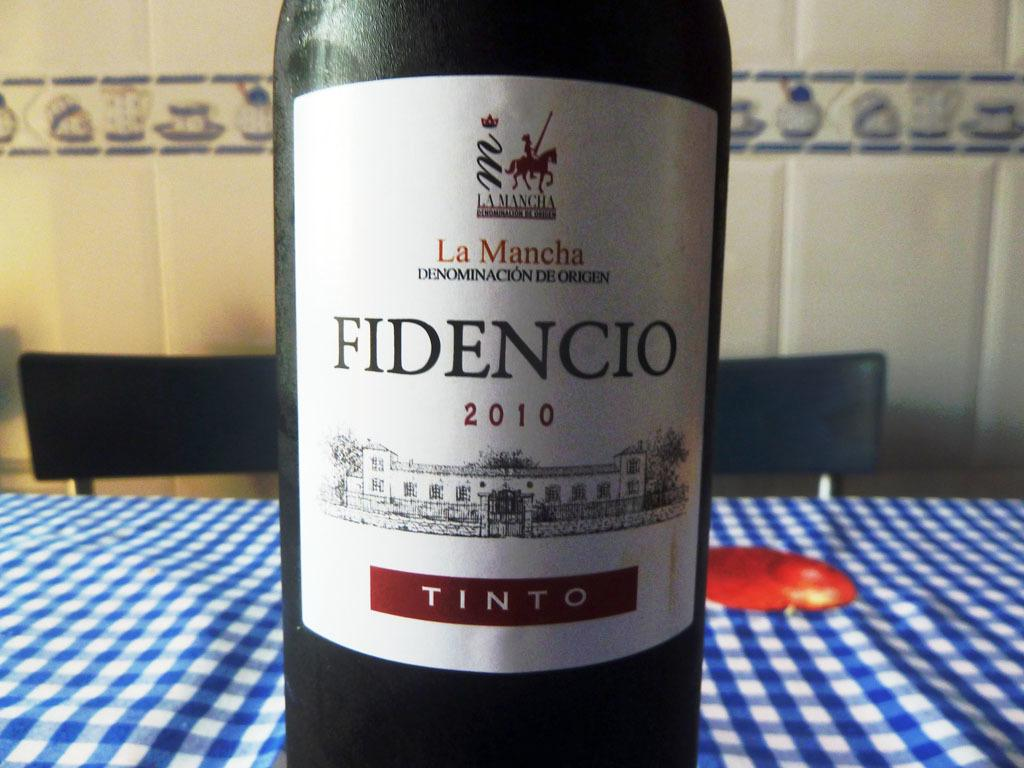<image>
Present a compact description of the photo's key features. A bottle of La Mancha Fidencio is set on a table with a blue and white table cloth draped over it. 